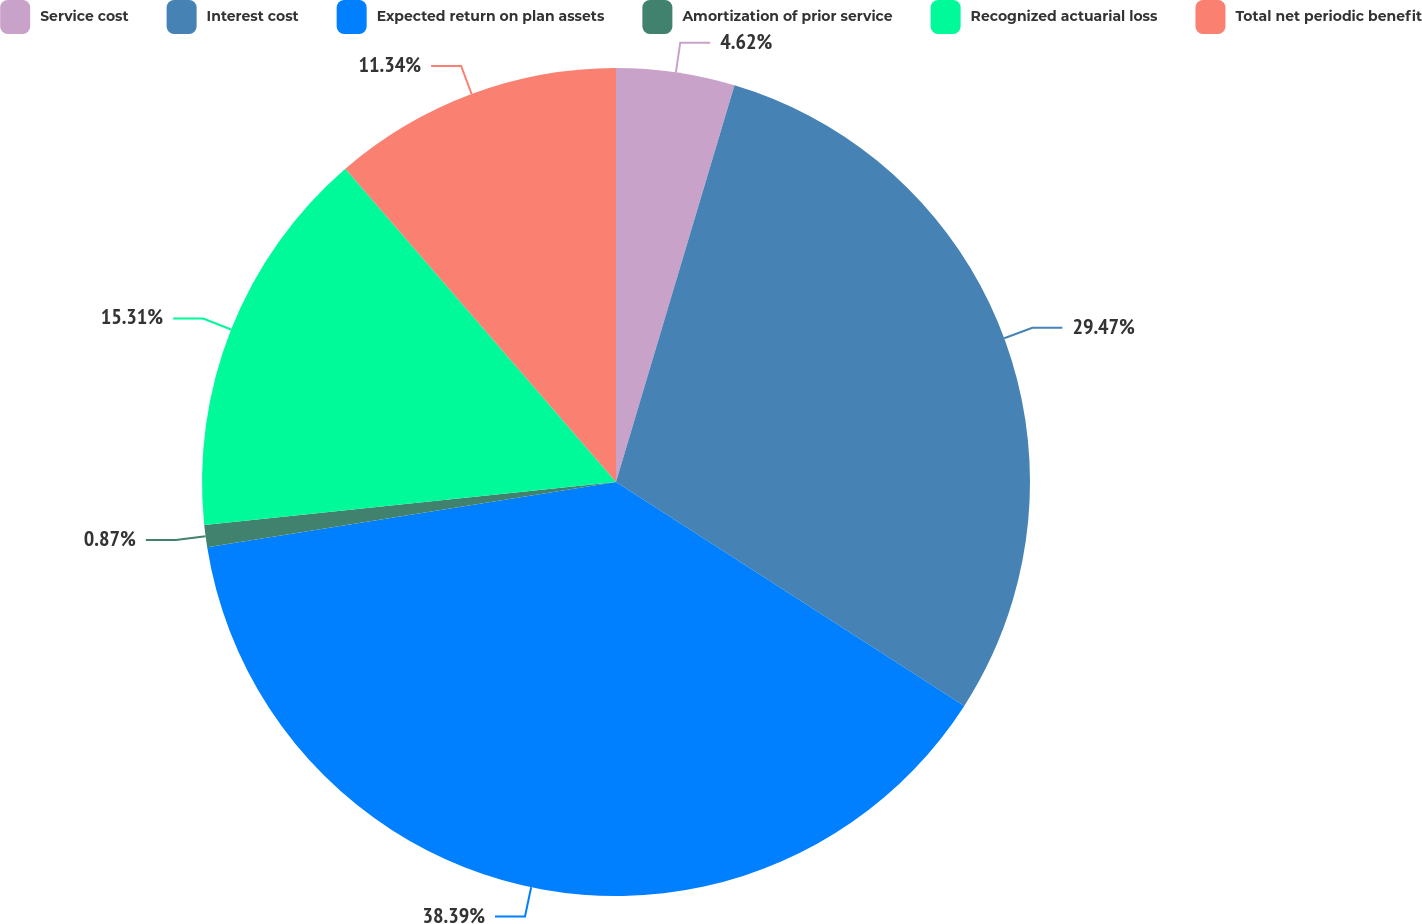Convert chart to OTSL. <chart><loc_0><loc_0><loc_500><loc_500><pie_chart><fcel>Service cost<fcel>Interest cost<fcel>Expected return on plan assets<fcel>Amortization of prior service<fcel>Recognized actuarial loss<fcel>Total net periodic benefit<nl><fcel>4.62%<fcel>29.47%<fcel>38.38%<fcel>0.87%<fcel>15.31%<fcel>11.34%<nl></chart> 